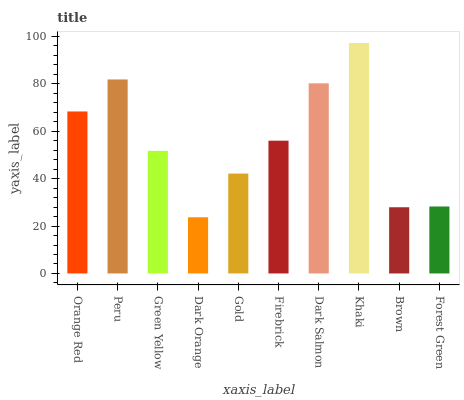Is Dark Orange the minimum?
Answer yes or no. Yes. Is Khaki the maximum?
Answer yes or no. Yes. Is Peru the minimum?
Answer yes or no. No. Is Peru the maximum?
Answer yes or no. No. Is Peru greater than Orange Red?
Answer yes or no. Yes. Is Orange Red less than Peru?
Answer yes or no. Yes. Is Orange Red greater than Peru?
Answer yes or no. No. Is Peru less than Orange Red?
Answer yes or no. No. Is Firebrick the high median?
Answer yes or no. Yes. Is Green Yellow the low median?
Answer yes or no. Yes. Is Dark Orange the high median?
Answer yes or no. No. Is Peru the low median?
Answer yes or no. No. 